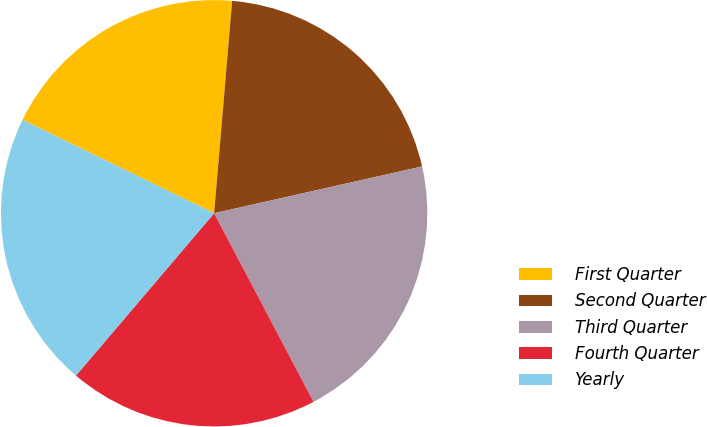Convert chart to OTSL. <chart><loc_0><loc_0><loc_500><loc_500><pie_chart><fcel>First Quarter<fcel>Second Quarter<fcel>Third Quarter<fcel>Fourth Quarter<fcel>Yearly<nl><fcel>19.13%<fcel>20.13%<fcel>20.81%<fcel>18.94%<fcel>21.0%<nl></chart> 